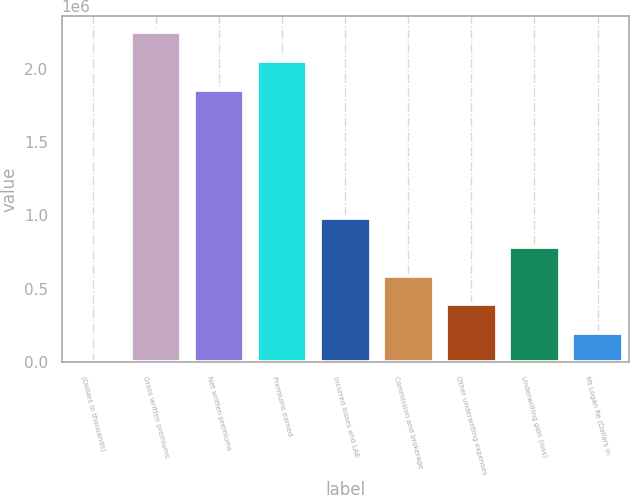<chart> <loc_0><loc_0><loc_500><loc_500><bar_chart><fcel>(Dollars in thousands)<fcel>Gross written premiums<fcel>Net written premiums<fcel>Premiums earned<fcel>Incurred losses and LAE<fcel>Commission and brokerage<fcel>Other underwriting expenses<fcel>Underwriting gain (loss)<fcel>Mt Logan Re (Dollars in<nl><fcel>2015<fcel>2.24814e+06<fcel>1.85585e+06<fcel>2.052e+06<fcel>982740<fcel>590450<fcel>394305<fcel>786595<fcel>198160<nl></chart> 